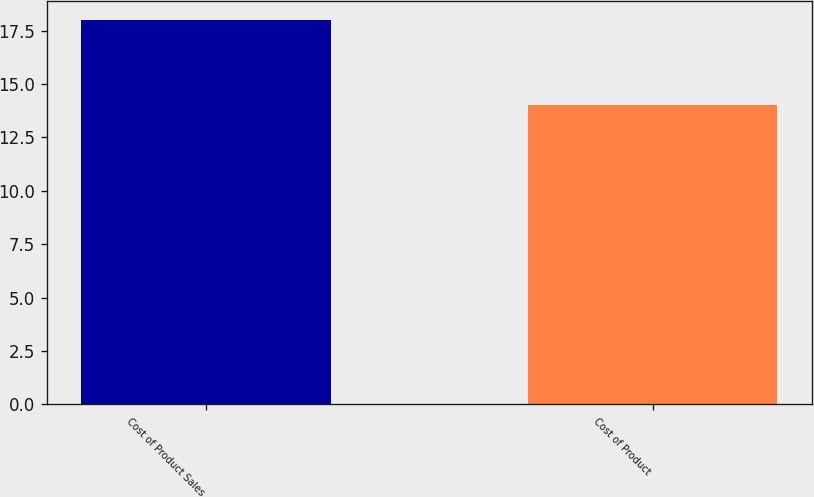Convert chart to OTSL. <chart><loc_0><loc_0><loc_500><loc_500><bar_chart><fcel>Cost of Product Sales<fcel>Cost of Product<nl><fcel>18<fcel>14<nl></chart> 